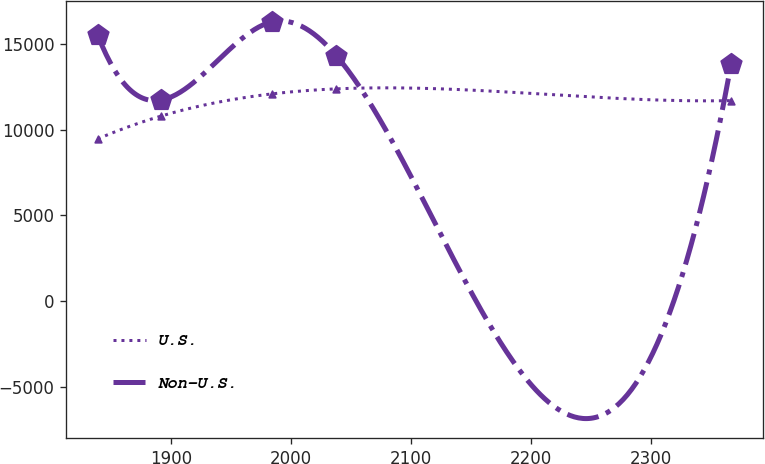Convert chart. <chart><loc_0><loc_0><loc_500><loc_500><line_chart><ecel><fcel>U.S.<fcel>Non-U.S.<nl><fcel>1838.58<fcel>9469.57<fcel>15534.3<nl><fcel>1891.44<fcel>10804.2<fcel>11738.5<nl><fcel>1984.42<fcel>12103.5<fcel>16313.3<nl><fcel>2037.57<fcel>12393.5<fcel>14339.8<nl><fcel>2367.21<fcel>11706.4<fcel>13859.3<nl></chart> 